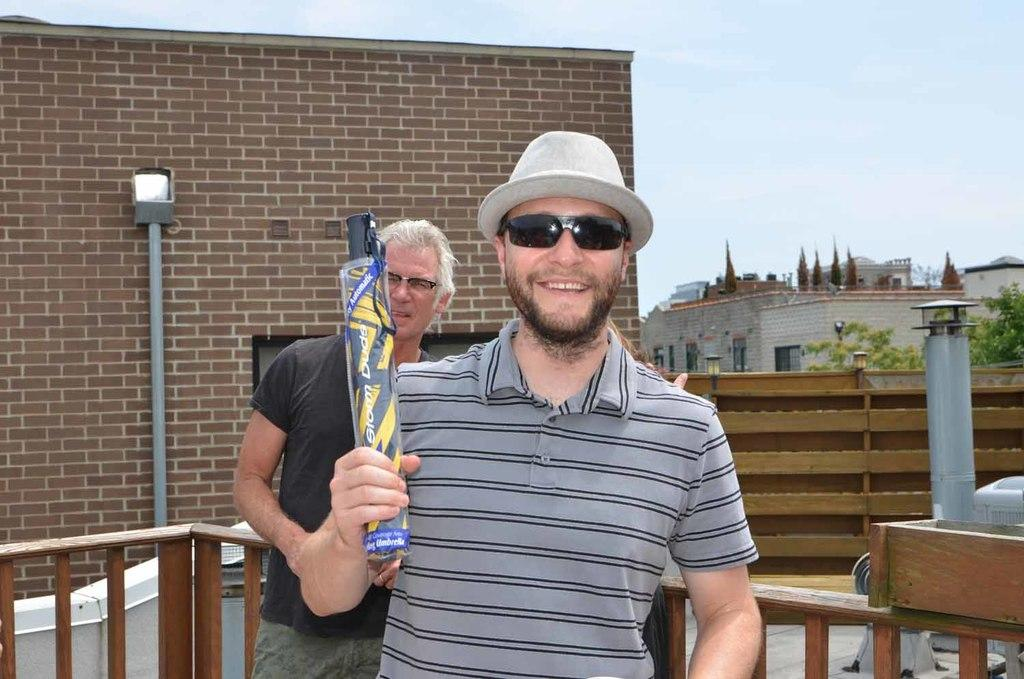How many people are in the image? There are two persons in the image. What is one person doing in the image? One person is holding an umbrella. Can you describe the person holding the umbrella? The person holding the umbrella is wearing glasses and a hat. What can be seen in the background of the image? There are buildings and the sky visible in the background of the image. How does the person with the umbrella help the account in the image? There is no account present in the image, and the person with the umbrella is not performing any actions related to an account. 